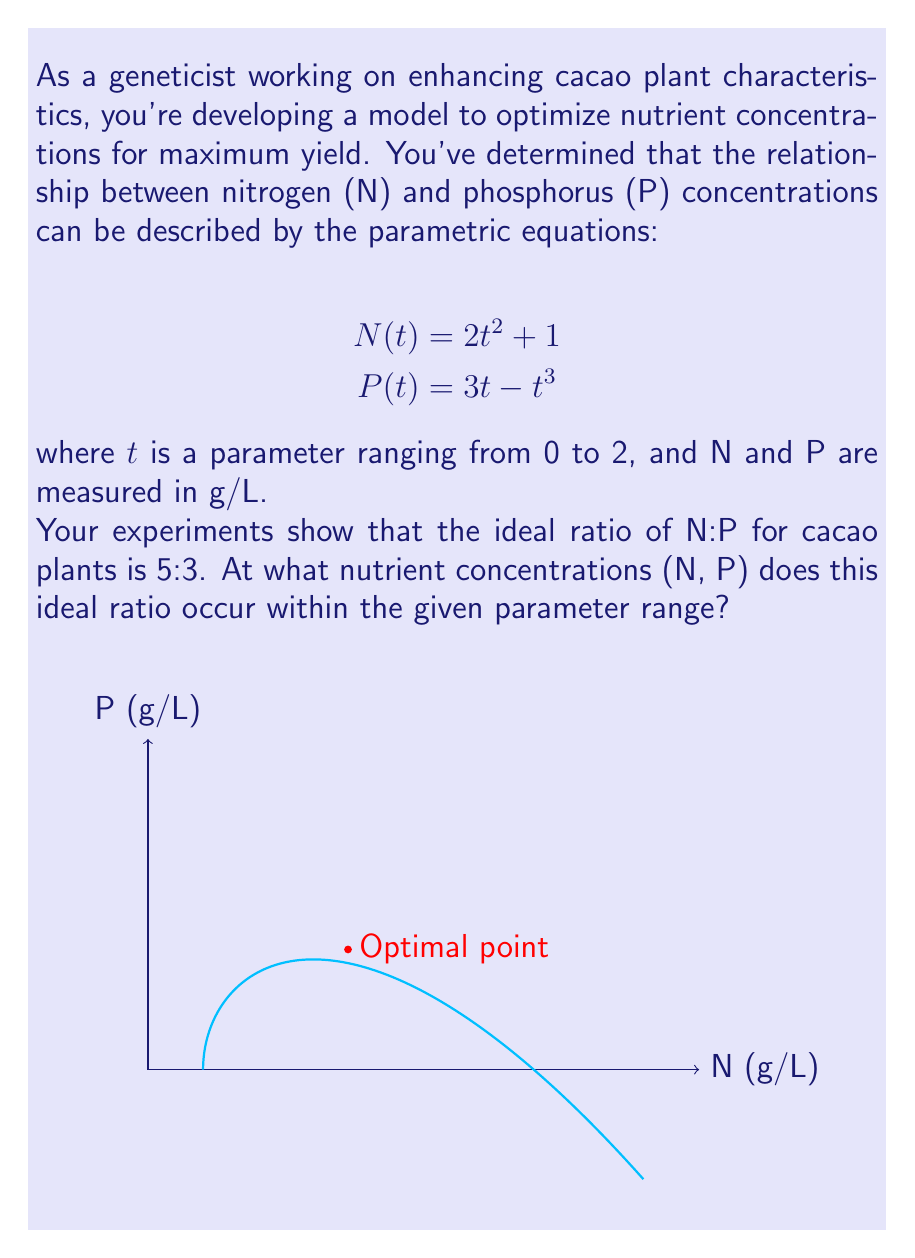Give your solution to this math problem. Let's approach this step-by-step:

1) The ideal ratio N:P = 5:3 can be expressed as:

   $$\frac{N}{P} = \frac{5}{3}$$

2) Substituting our parametric equations:

   $$\frac{2t^2 + 1}{3t - t^3} = \frac{5}{3}$$

3) Cross-multiply:

   $$3(2t^2 + 1) = 5(3t - t^3)$$

4) Expand:

   $$6t^2 + 3 = 15t - 5t^3$$

5) Rearrange to standard form:

   $$5t^3 + 6t^2 - 15t + 3 = 0$$

6) This cubic equation can be solved numerically. Using a calculator or computer algebra system, we find that within the range 0 ≤ t ≤ 2, there is one solution:

   $$t ≈ 1.14815$$

7) Now, we can substitute this t-value back into our original parametric equations:

   $$N = 2(1.14815)^2 + 1 ≈ 3.63636 \text{ g/L}$$
   $$P = 3(1.14815) - (1.14815)^3 ≈ 2.18182 \text{ g/L}$$

8) We can verify the ratio:

   $$\frac{3.63636}{2.18182} ≈ \frac{5}{3}$$

Therefore, the ideal nutrient concentrations occur at approximately (3.63636, 2.18182) g/L for (N, P) respectively.
Answer: (3.64, 2.18) g/L 